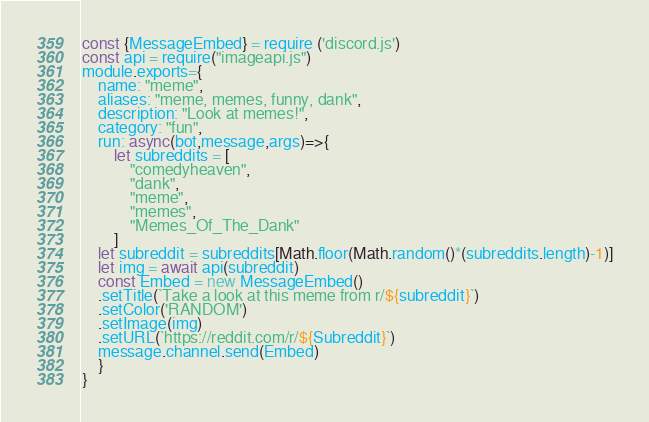<code> <loc_0><loc_0><loc_500><loc_500><_JavaScript_>const {MessageEmbed} = require ('discord.js')
const api = require("imageapi.js")
module.exports={
    name: "meme",
    aliases: "meme, memes, funny, dank", 
    description: "Look at memes!", 
    category: "fun", 
    run: async(bot,message,args)=>{
        let subreddits = [
            "comedyheaven",
            "dank",
            "meme",
            "memes", 
            "Memes_Of_The_Dank"
        ]
    let subreddit = subreddits[Math.floor(Math.random()*(subreddits.length)-1)]
    let img = await api(subreddit)
    const Embed = new MessageEmbed()
    .setTitle(`Take a look at this meme from r/${subreddit}`)
    .setColor('RANDOM')
    .setImage(img)
    .setURL(`https://reddit.com/r/${Subreddit}`)
    message.channel.send(Embed)
    }
}
</code> 